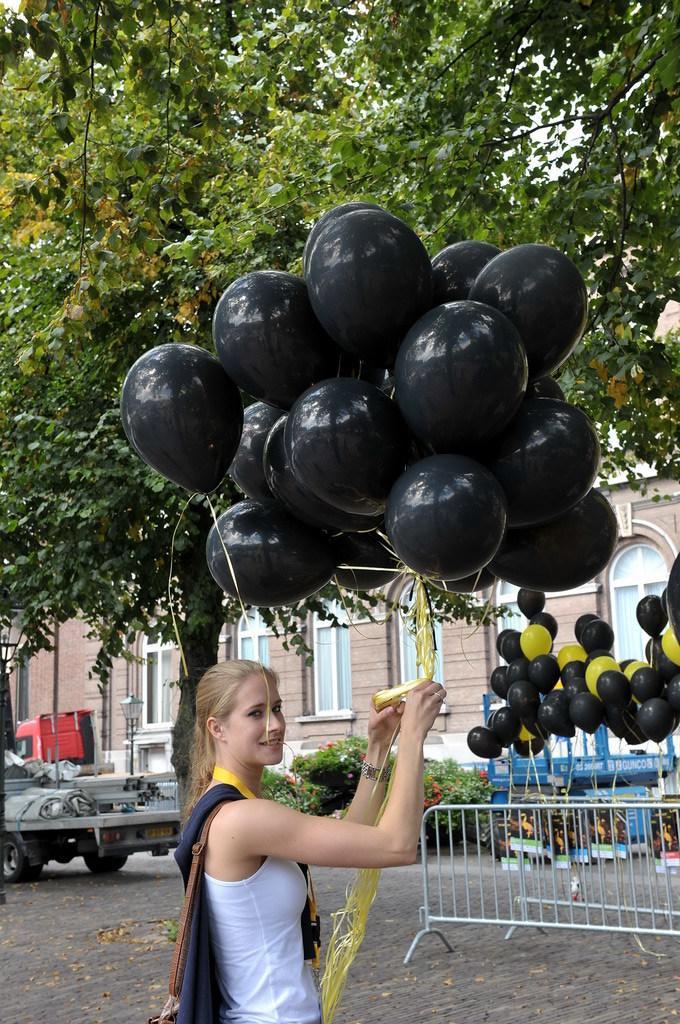Can you describe this image briefly? In this image, we can see a woman standing and she is holding some balloons, we can see a steel stand, there are some balloons, we can see a vehicle, there are some green trees, we can see a building and some windows on the building. 